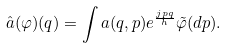Convert formula to latex. <formula><loc_0><loc_0><loc_500><loc_500>\hat { a } ( \varphi ) ( q ) = \int a ( q , p ) e ^ { \frac { j p q } { h } } \tilde { \varphi } ( d p ) .</formula> 